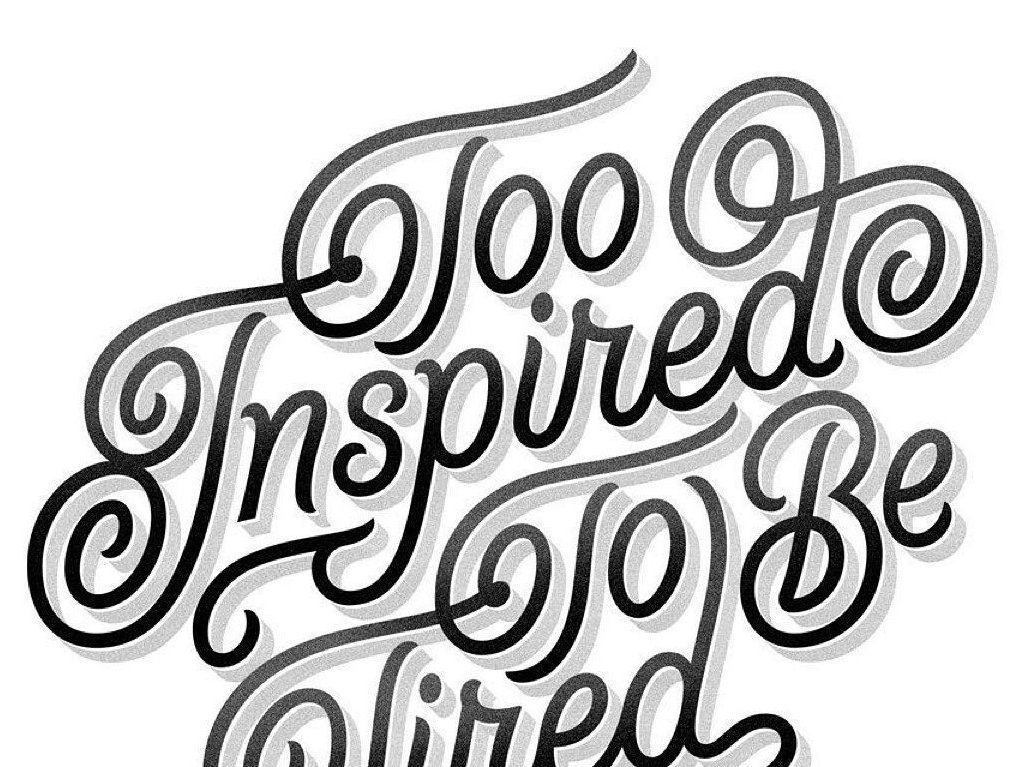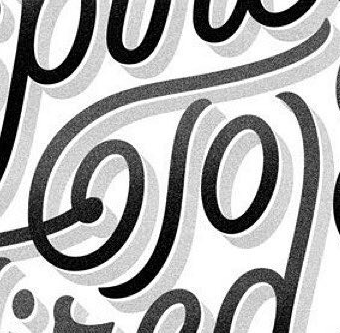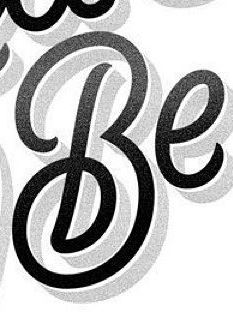What words can you see in these images in sequence, separated by a semicolon? Inspired; To; Be 